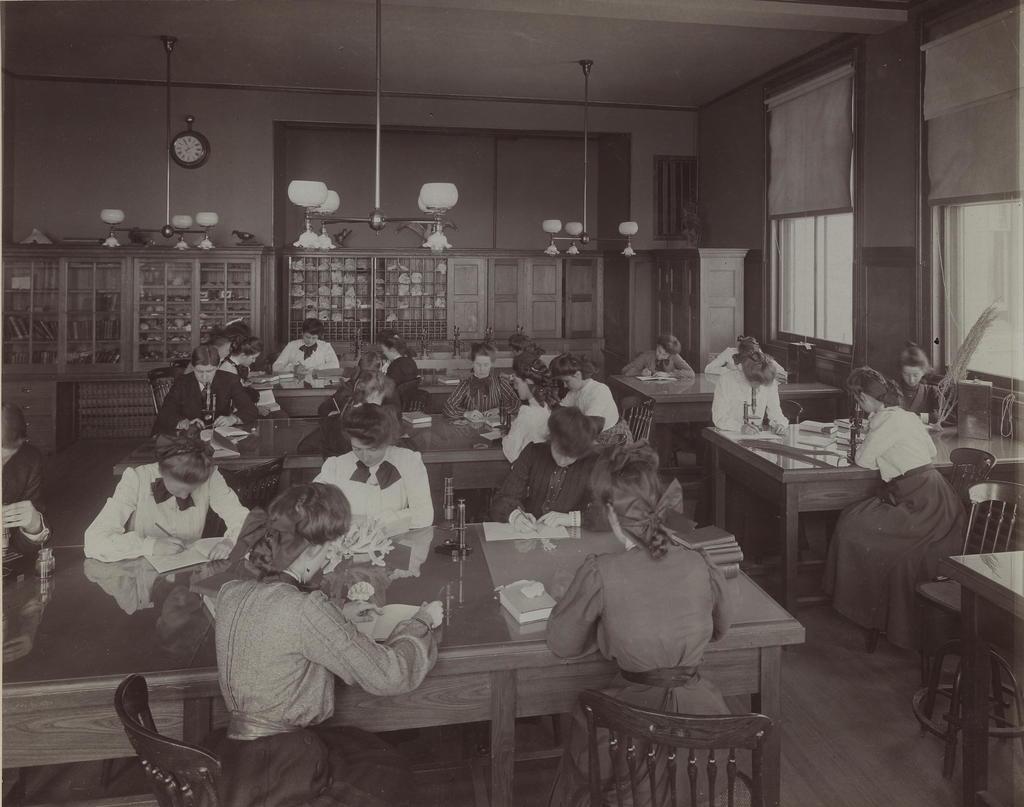How would you summarize this image in a sentence or two? At the top we can see ceiling, lights and fans. We can see a clock over a wall. These are windows. Here we can see all the persons sitting on chairs in front of a table and on the table we can see flower vase, books and few persons holding pen in their hands and writing. This is a floor. 